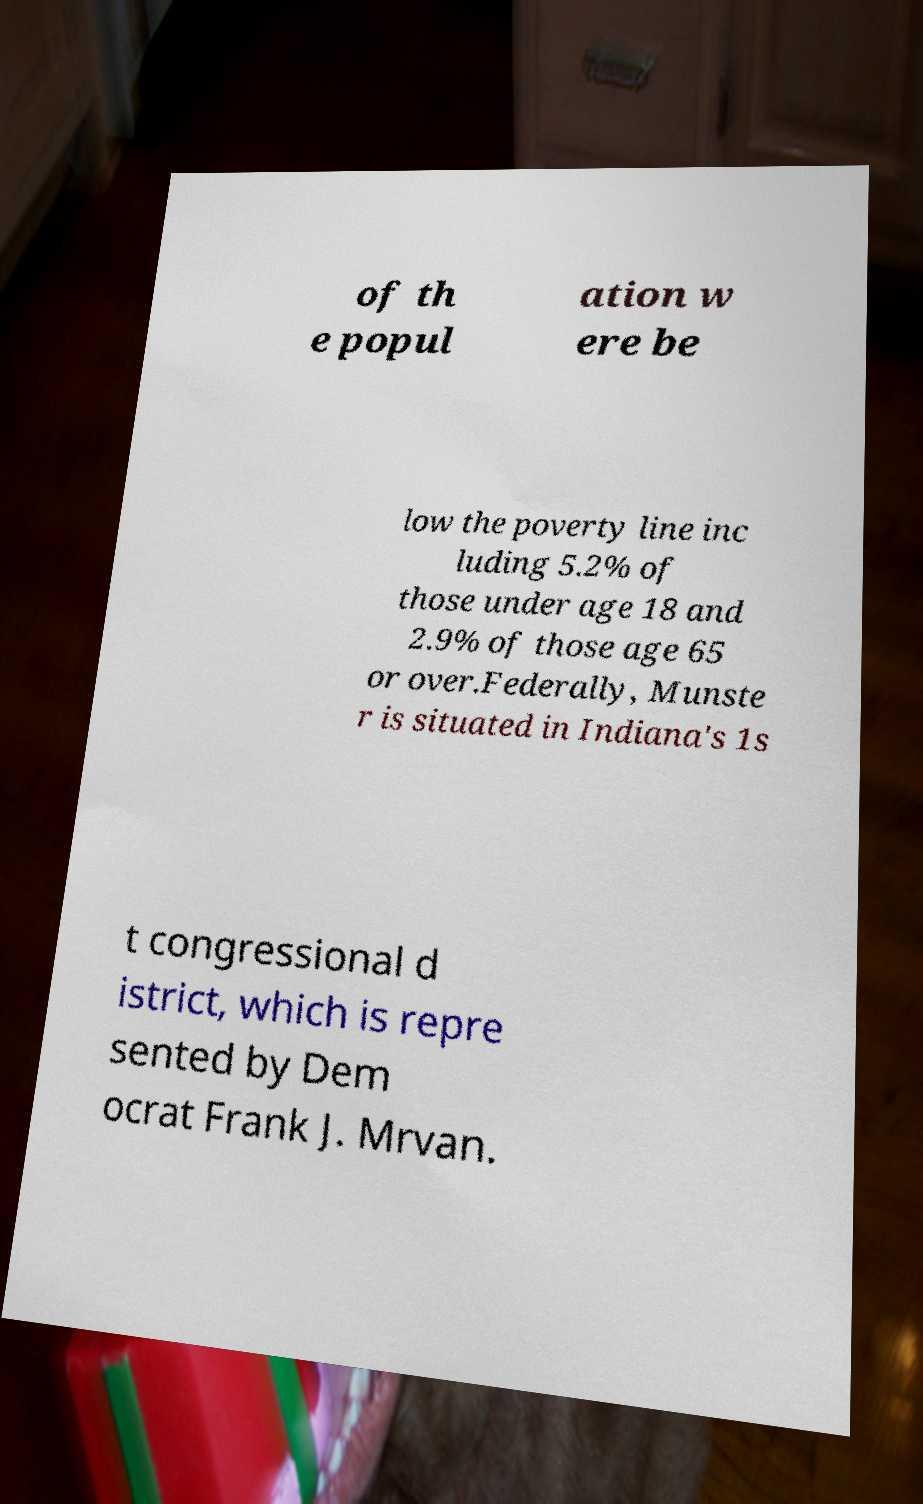There's text embedded in this image that I need extracted. Can you transcribe it verbatim? of th e popul ation w ere be low the poverty line inc luding 5.2% of those under age 18 and 2.9% of those age 65 or over.Federally, Munste r is situated in Indiana's 1s t congressional d istrict, which is repre sented by Dem ocrat Frank J. Mrvan. 